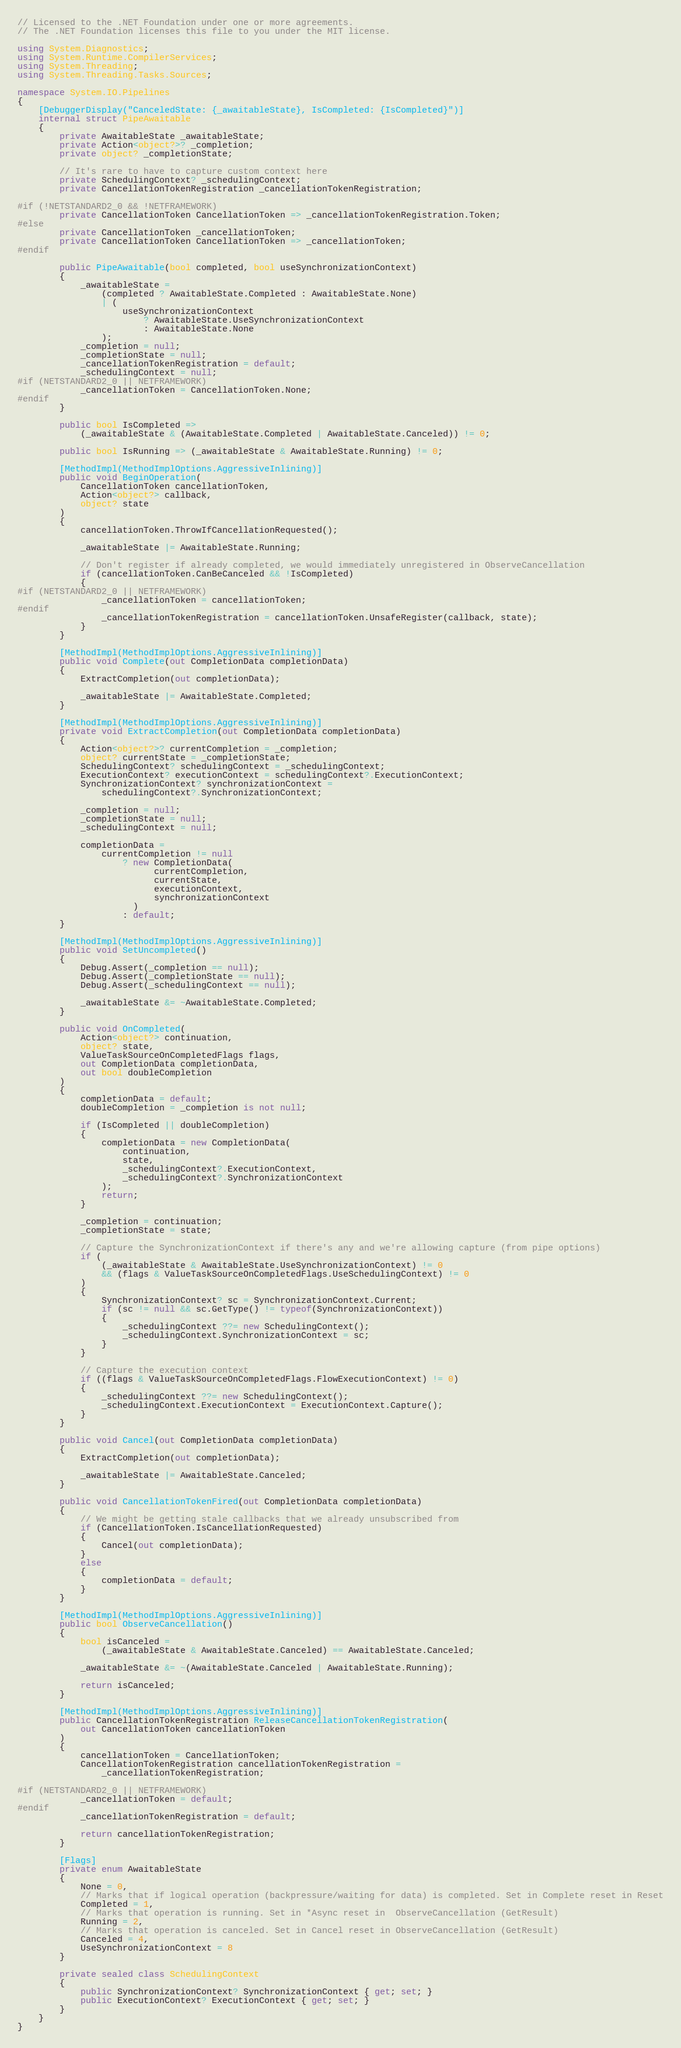<code> <loc_0><loc_0><loc_500><loc_500><_C#_>// Licensed to the .NET Foundation under one or more agreements.
// The .NET Foundation licenses this file to you under the MIT license.

using System.Diagnostics;
using System.Runtime.CompilerServices;
using System.Threading;
using System.Threading.Tasks.Sources;

namespace System.IO.Pipelines
{
    [DebuggerDisplay("CanceledState: {_awaitableState}, IsCompleted: {IsCompleted}")]
    internal struct PipeAwaitable
    {
        private AwaitableState _awaitableState;
        private Action<object?>? _completion;
        private object? _completionState;

        // It's rare to have to capture custom context here
        private SchedulingContext? _schedulingContext;
        private CancellationTokenRegistration _cancellationTokenRegistration;

#if (!NETSTANDARD2_0 && !NETFRAMEWORK)
        private CancellationToken CancellationToken => _cancellationTokenRegistration.Token;
#else
        private CancellationToken _cancellationToken;
        private CancellationToken CancellationToken => _cancellationToken;
#endif

        public PipeAwaitable(bool completed, bool useSynchronizationContext)
        {
            _awaitableState =
                (completed ? AwaitableState.Completed : AwaitableState.None)
                | (
                    useSynchronizationContext
                        ? AwaitableState.UseSynchronizationContext
                        : AwaitableState.None
                );
            _completion = null;
            _completionState = null;
            _cancellationTokenRegistration = default;
            _schedulingContext = null;
#if (NETSTANDARD2_0 || NETFRAMEWORK)
            _cancellationToken = CancellationToken.None;
#endif
        }

        public bool IsCompleted =>
            (_awaitableState & (AwaitableState.Completed | AwaitableState.Canceled)) != 0;

        public bool IsRunning => (_awaitableState & AwaitableState.Running) != 0;

        [MethodImpl(MethodImplOptions.AggressiveInlining)]
        public void BeginOperation(
            CancellationToken cancellationToken,
            Action<object?> callback,
            object? state
        )
        {
            cancellationToken.ThrowIfCancellationRequested();

            _awaitableState |= AwaitableState.Running;

            // Don't register if already completed, we would immediately unregistered in ObserveCancellation
            if (cancellationToken.CanBeCanceled && !IsCompleted)
            {
#if (NETSTANDARD2_0 || NETFRAMEWORK)
                _cancellationToken = cancellationToken;
#endif
                _cancellationTokenRegistration = cancellationToken.UnsafeRegister(callback, state);
            }
        }

        [MethodImpl(MethodImplOptions.AggressiveInlining)]
        public void Complete(out CompletionData completionData)
        {
            ExtractCompletion(out completionData);

            _awaitableState |= AwaitableState.Completed;
        }

        [MethodImpl(MethodImplOptions.AggressiveInlining)]
        private void ExtractCompletion(out CompletionData completionData)
        {
            Action<object?>? currentCompletion = _completion;
            object? currentState = _completionState;
            SchedulingContext? schedulingContext = _schedulingContext;
            ExecutionContext? executionContext = schedulingContext?.ExecutionContext;
            SynchronizationContext? synchronizationContext =
                schedulingContext?.SynchronizationContext;

            _completion = null;
            _completionState = null;
            _schedulingContext = null;

            completionData =
                currentCompletion != null
                    ? new CompletionData(
                          currentCompletion,
                          currentState,
                          executionContext,
                          synchronizationContext
                      )
                    : default;
        }

        [MethodImpl(MethodImplOptions.AggressiveInlining)]
        public void SetUncompleted()
        {
            Debug.Assert(_completion == null);
            Debug.Assert(_completionState == null);
            Debug.Assert(_schedulingContext == null);

            _awaitableState &= ~AwaitableState.Completed;
        }

        public void OnCompleted(
            Action<object?> continuation,
            object? state,
            ValueTaskSourceOnCompletedFlags flags,
            out CompletionData completionData,
            out bool doubleCompletion
        )
        {
            completionData = default;
            doubleCompletion = _completion is not null;

            if (IsCompleted || doubleCompletion)
            {
                completionData = new CompletionData(
                    continuation,
                    state,
                    _schedulingContext?.ExecutionContext,
                    _schedulingContext?.SynchronizationContext
                );
                return;
            }

            _completion = continuation;
            _completionState = state;

            // Capture the SynchronizationContext if there's any and we're allowing capture (from pipe options)
            if (
                (_awaitableState & AwaitableState.UseSynchronizationContext) != 0
                && (flags & ValueTaskSourceOnCompletedFlags.UseSchedulingContext) != 0
            )
            {
                SynchronizationContext? sc = SynchronizationContext.Current;
                if (sc != null && sc.GetType() != typeof(SynchronizationContext))
                {
                    _schedulingContext ??= new SchedulingContext();
                    _schedulingContext.SynchronizationContext = sc;
                }
            }

            // Capture the execution context
            if ((flags & ValueTaskSourceOnCompletedFlags.FlowExecutionContext) != 0)
            {
                _schedulingContext ??= new SchedulingContext();
                _schedulingContext.ExecutionContext = ExecutionContext.Capture();
            }
        }

        public void Cancel(out CompletionData completionData)
        {
            ExtractCompletion(out completionData);

            _awaitableState |= AwaitableState.Canceled;
        }

        public void CancellationTokenFired(out CompletionData completionData)
        {
            // We might be getting stale callbacks that we already unsubscribed from
            if (CancellationToken.IsCancellationRequested)
            {
                Cancel(out completionData);
            }
            else
            {
                completionData = default;
            }
        }

        [MethodImpl(MethodImplOptions.AggressiveInlining)]
        public bool ObserveCancellation()
        {
            bool isCanceled =
                (_awaitableState & AwaitableState.Canceled) == AwaitableState.Canceled;

            _awaitableState &= ~(AwaitableState.Canceled | AwaitableState.Running);

            return isCanceled;
        }

        [MethodImpl(MethodImplOptions.AggressiveInlining)]
        public CancellationTokenRegistration ReleaseCancellationTokenRegistration(
            out CancellationToken cancellationToken
        )
        {
            cancellationToken = CancellationToken;
            CancellationTokenRegistration cancellationTokenRegistration =
                _cancellationTokenRegistration;

#if (NETSTANDARD2_0 || NETFRAMEWORK)
            _cancellationToken = default;
#endif
            _cancellationTokenRegistration = default;

            return cancellationTokenRegistration;
        }

        [Flags]
        private enum AwaitableState
        {
            None = 0,
            // Marks that if logical operation (backpressure/waiting for data) is completed. Set in Complete reset in Reset
            Completed = 1,
            // Marks that operation is running. Set in *Async reset in  ObserveCancellation (GetResult)
            Running = 2,
            // Marks that operation is canceled. Set in Cancel reset in ObserveCancellation (GetResult)
            Canceled = 4,
            UseSynchronizationContext = 8
        }

        private sealed class SchedulingContext
        {
            public SynchronizationContext? SynchronizationContext { get; set; }
            public ExecutionContext? ExecutionContext { get; set; }
        }
    }
}
</code> 